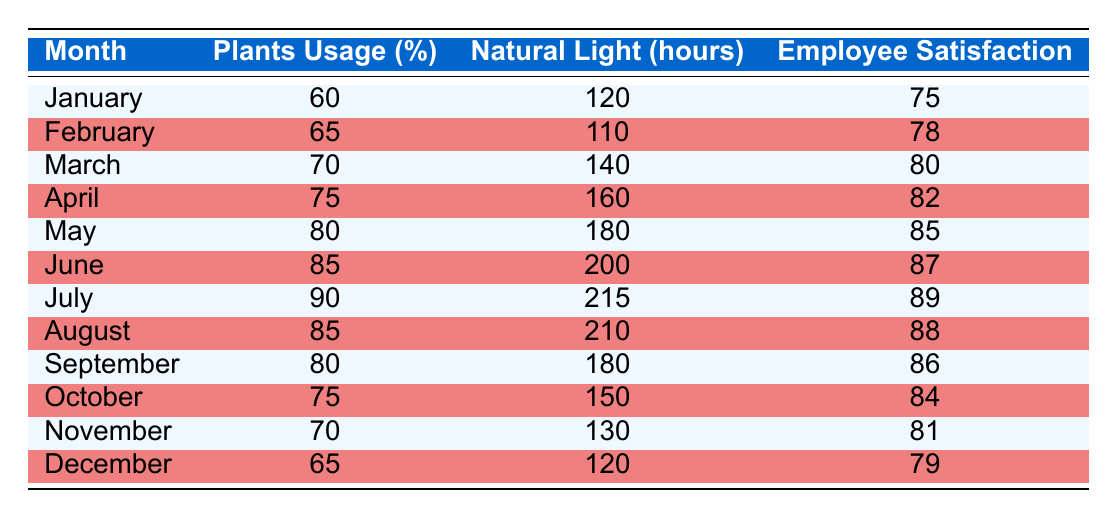What was the employee satisfaction score in March? According to the table, the employee satisfaction score for March is directly listed as 80.
Answer: 80 What month had the highest usage percentage of plants? By examining the table, July shows the highest plants usage percentage at 90%.
Answer: July What is the average number of natural light hours over the year? To find the average, sum the natural light hours for each month (120 + 110 + 140 + 160 + 180 + 200 + 215 + 210 + 180 + 150 + 130 + 120 = 1,765) and divide by 12 (1,765 / 12 = 147.08).
Answer: 147.08 Did employee satisfaction score increase every month? Analyzing the employee satisfaction scores, they do not consistently increase; for example, the score decreased from 89 in July to 88 in August.
Answer: No How many months had plants usage percentages above 70%? From the table, the months with plants usage percentages above 70% are March, April, May, June, July, and August. This counts to 6 months.
Answer: 6 What is the difference in natural light hours between January and April? The natural light hours in January are 120, and in April they are 160. Subtract January's hours from April's: 160 - 120 = 40.
Answer: 40 Which month had the lowest plants usage percentage? The table shows January with the lowest plants usage percentage at 60%.
Answer: January What was the employee satisfaction score in June compared to December? June's score is 87, while December's is 79. The difference is 87 - 79 = 8, showing June has a higher score by 8.
Answer: 8 How did the natural light hours change from May to October? Natural light hours in May are 180, and in October they are 150. The change is 150 - 180 = -30, indicating a decrease of 30 hours.
Answer: -30 